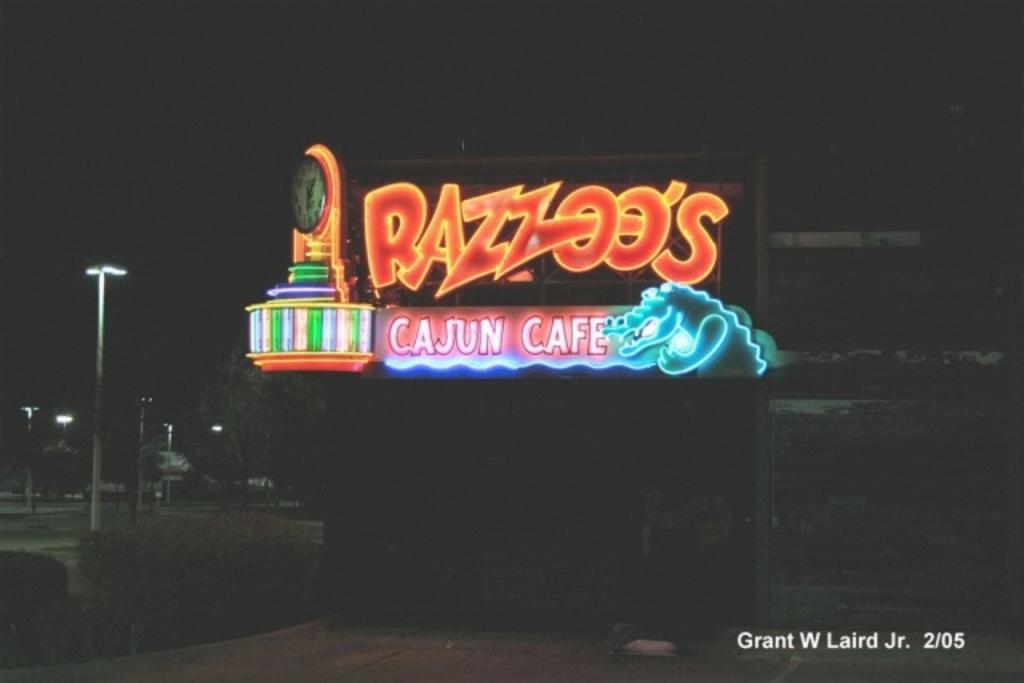<image>
Offer a succinct explanation of the picture presented. A light up sign for Razzoo's Cajun Cafe 